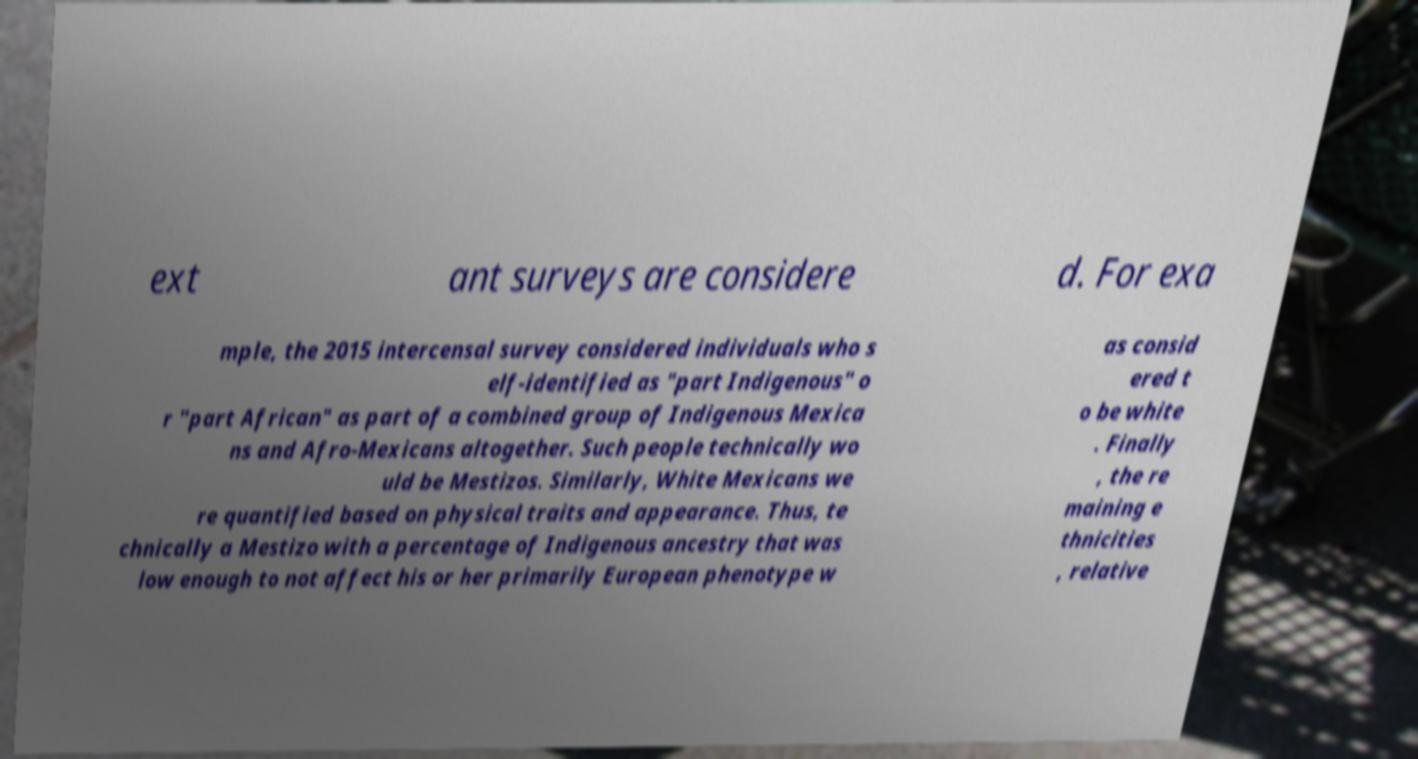Please identify and transcribe the text found in this image. ext ant surveys are considere d. For exa mple, the 2015 intercensal survey considered individuals who s elf-identified as "part Indigenous" o r "part African" as part of a combined group of Indigenous Mexica ns and Afro-Mexicans altogether. Such people technically wo uld be Mestizos. Similarly, White Mexicans we re quantified based on physical traits and appearance. Thus, te chnically a Mestizo with a percentage of Indigenous ancestry that was low enough to not affect his or her primarily European phenotype w as consid ered t o be white . Finally , the re maining e thnicities , relative 